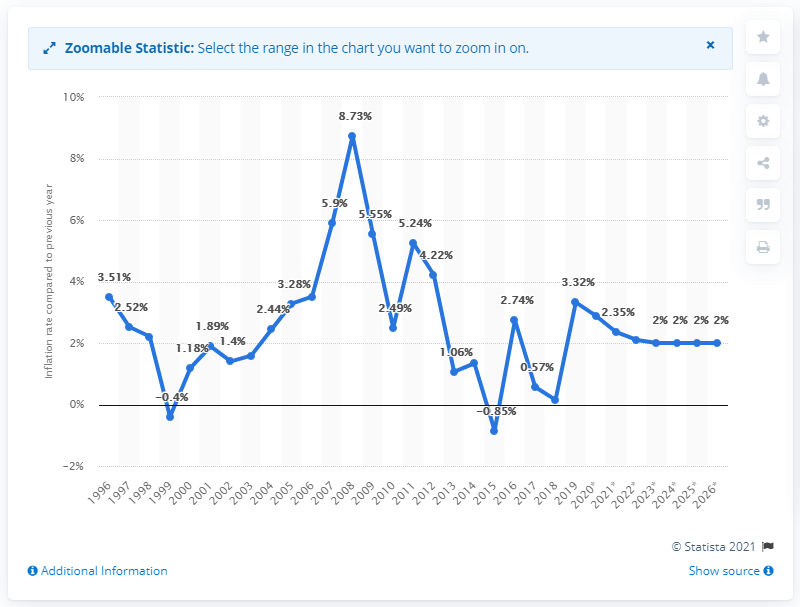Mention a couple of crucial points in this snapshot. In 1996, the average inflation rate in Djibouti was X. In 2019, the inflation rate in Djibouti was 3.32%. 